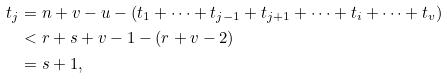Convert formula to latex. <formula><loc_0><loc_0><loc_500><loc_500>t _ { j } & = n + v - u - ( t _ { 1 } + \cdots + t _ { j - 1 } + t _ { j + 1 } + \cdots + t _ { i } + \cdots + t _ { v } ) \\ & < r + s + v - 1 - ( r + v - 2 ) \\ & = s + 1 ,</formula> 